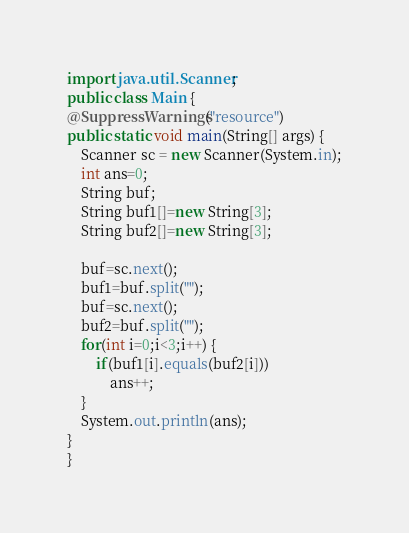Convert code to text. <code><loc_0><loc_0><loc_500><loc_500><_Java_>import java.util.Scanner;
public class Main {
@SuppressWarnings("resource")
public static void main(String[] args) {
	Scanner sc = new Scanner(System.in);
	int ans=0;
	String buf;
	String buf1[]=new String[3];
	String buf2[]=new String[3];

	buf=sc.next();
	buf1=buf.split("");
	buf=sc.next();
	buf2=buf.split("");
	for(int i=0;i<3;i++) {
		if(buf1[i].equals(buf2[i]))
			ans++;
	}
	System.out.println(ans);
}
}
</code> 